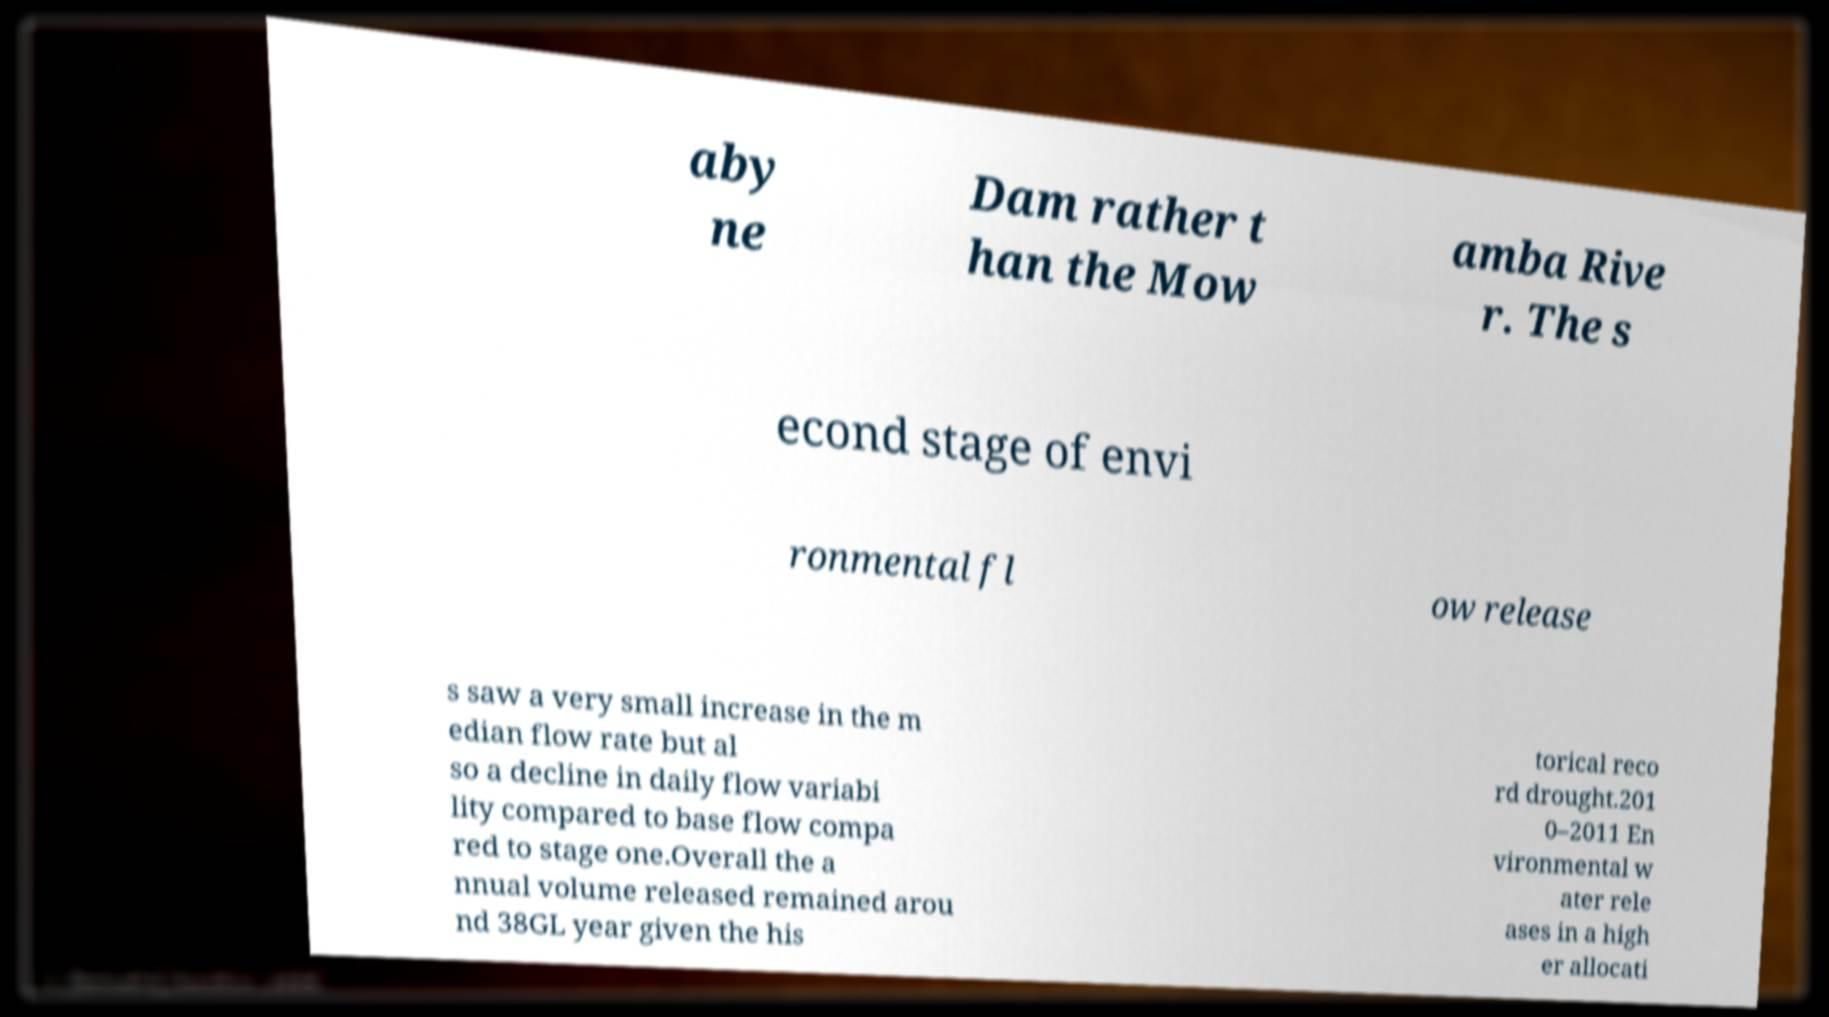Please identify and transcribe the text found in this image. aby ne Dam rather t han the Mow amba Rive r. The s econd stage of envi ronmental fl ow release s saw a very small increase in the m edian flow rate but al so a decline in daily flow variabi lity compared to base flow compa red to stage one.Overall the a nnual volume released remained arou nd 38GL year given the his torical reco rd drought.201 0–2011 En vironmental w ater rele ases in a high er allocati 